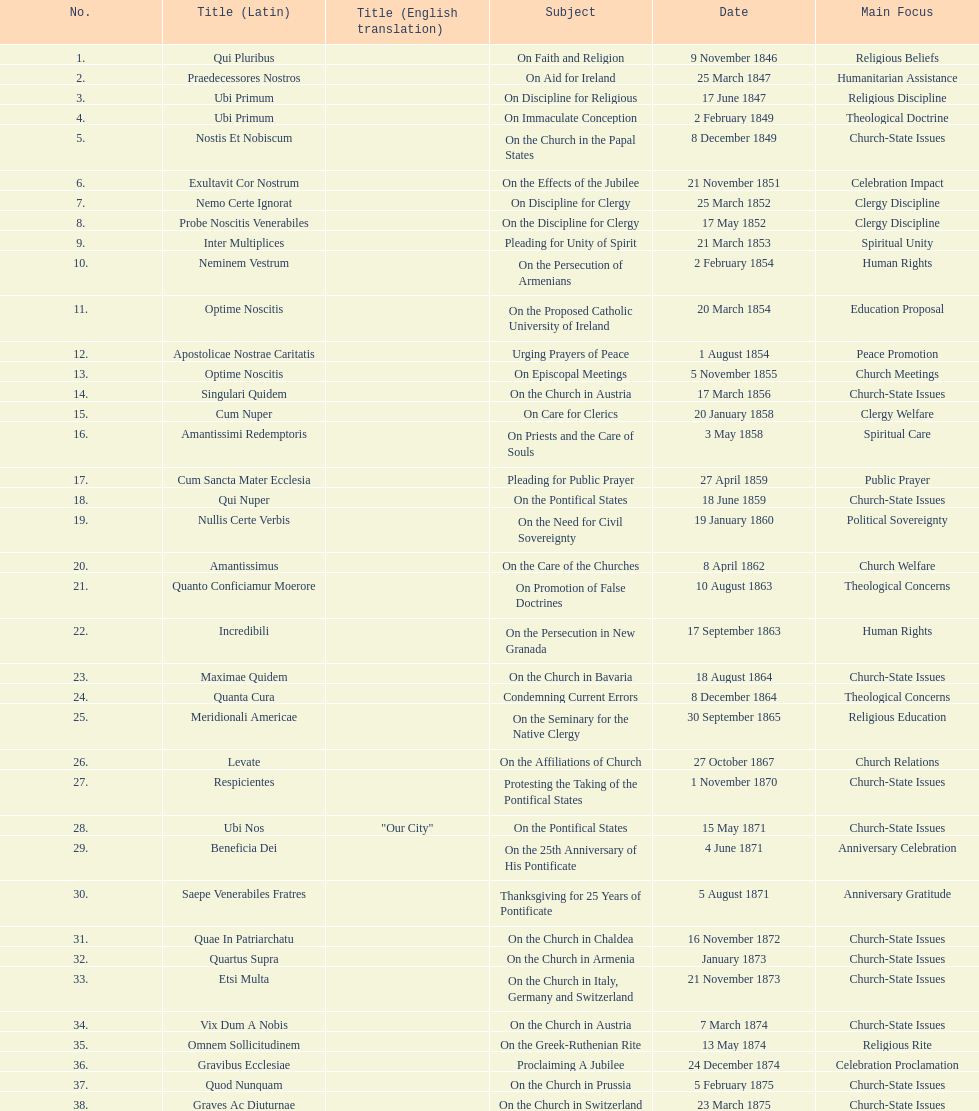What is the total number of title? 38. 